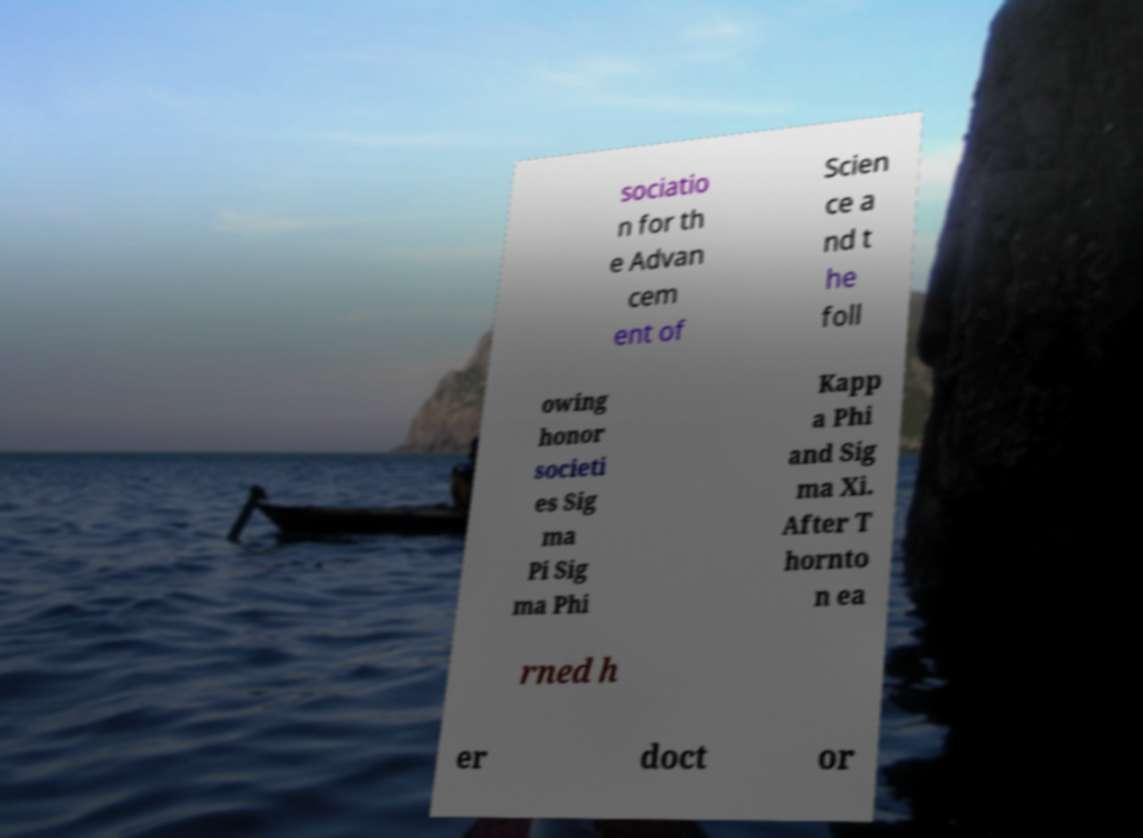Could you extract and type out the text from this image? sociatio n for th e Advan cem ent of Scien ce a nd t he foll owing honor societi es Sig ma Pi Sig ma Phi Kapp a Phi and Sig ma Xi. After T hornto n ea rned h er doct or 